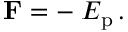<formula> <loc_0><loc_0><loc_500><loc_500>F = - \nabla E _ { p } \, .</formula> 